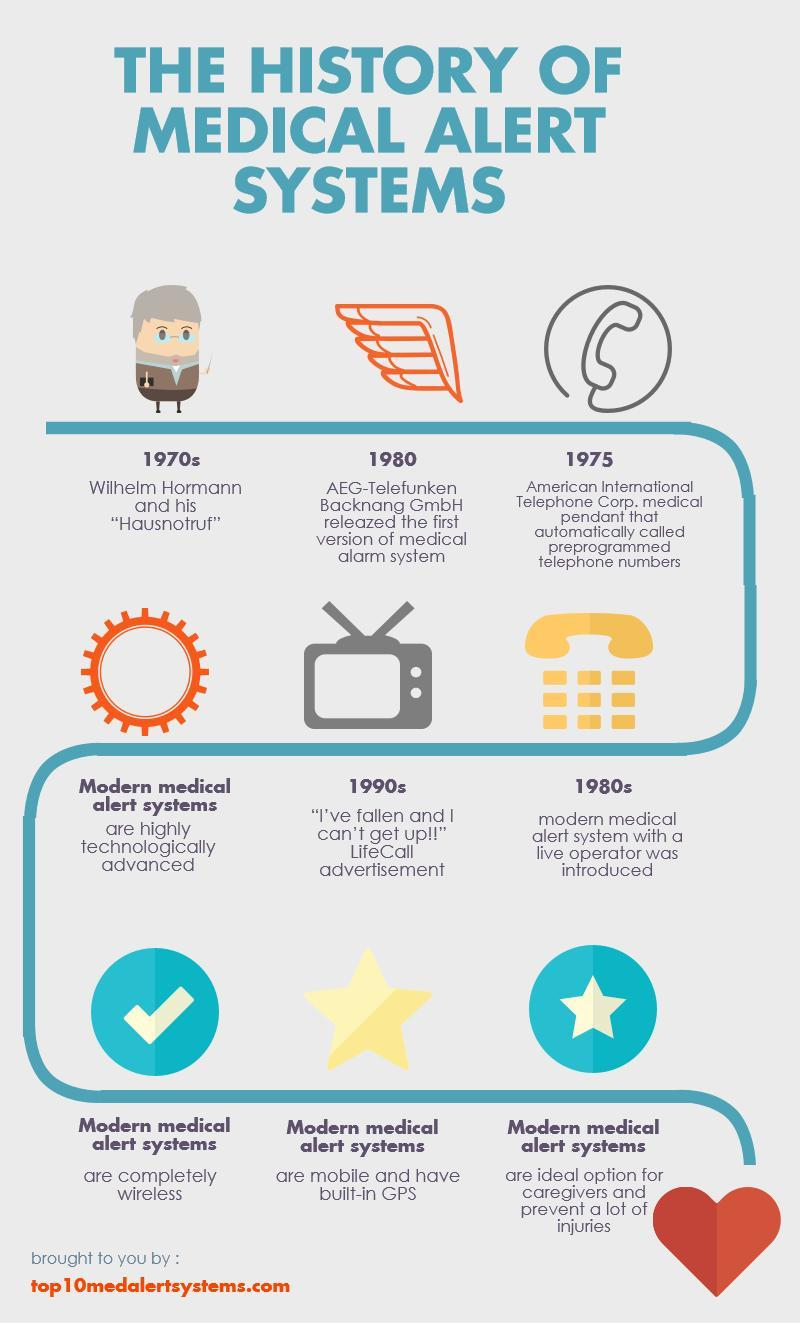When was modern medical alert system with a live operator was introduced
Answer the question with a short phrase. 1980s what are completely wireless modern medical alert systems What are mobile and have built-in GPS modern medical alert systems 